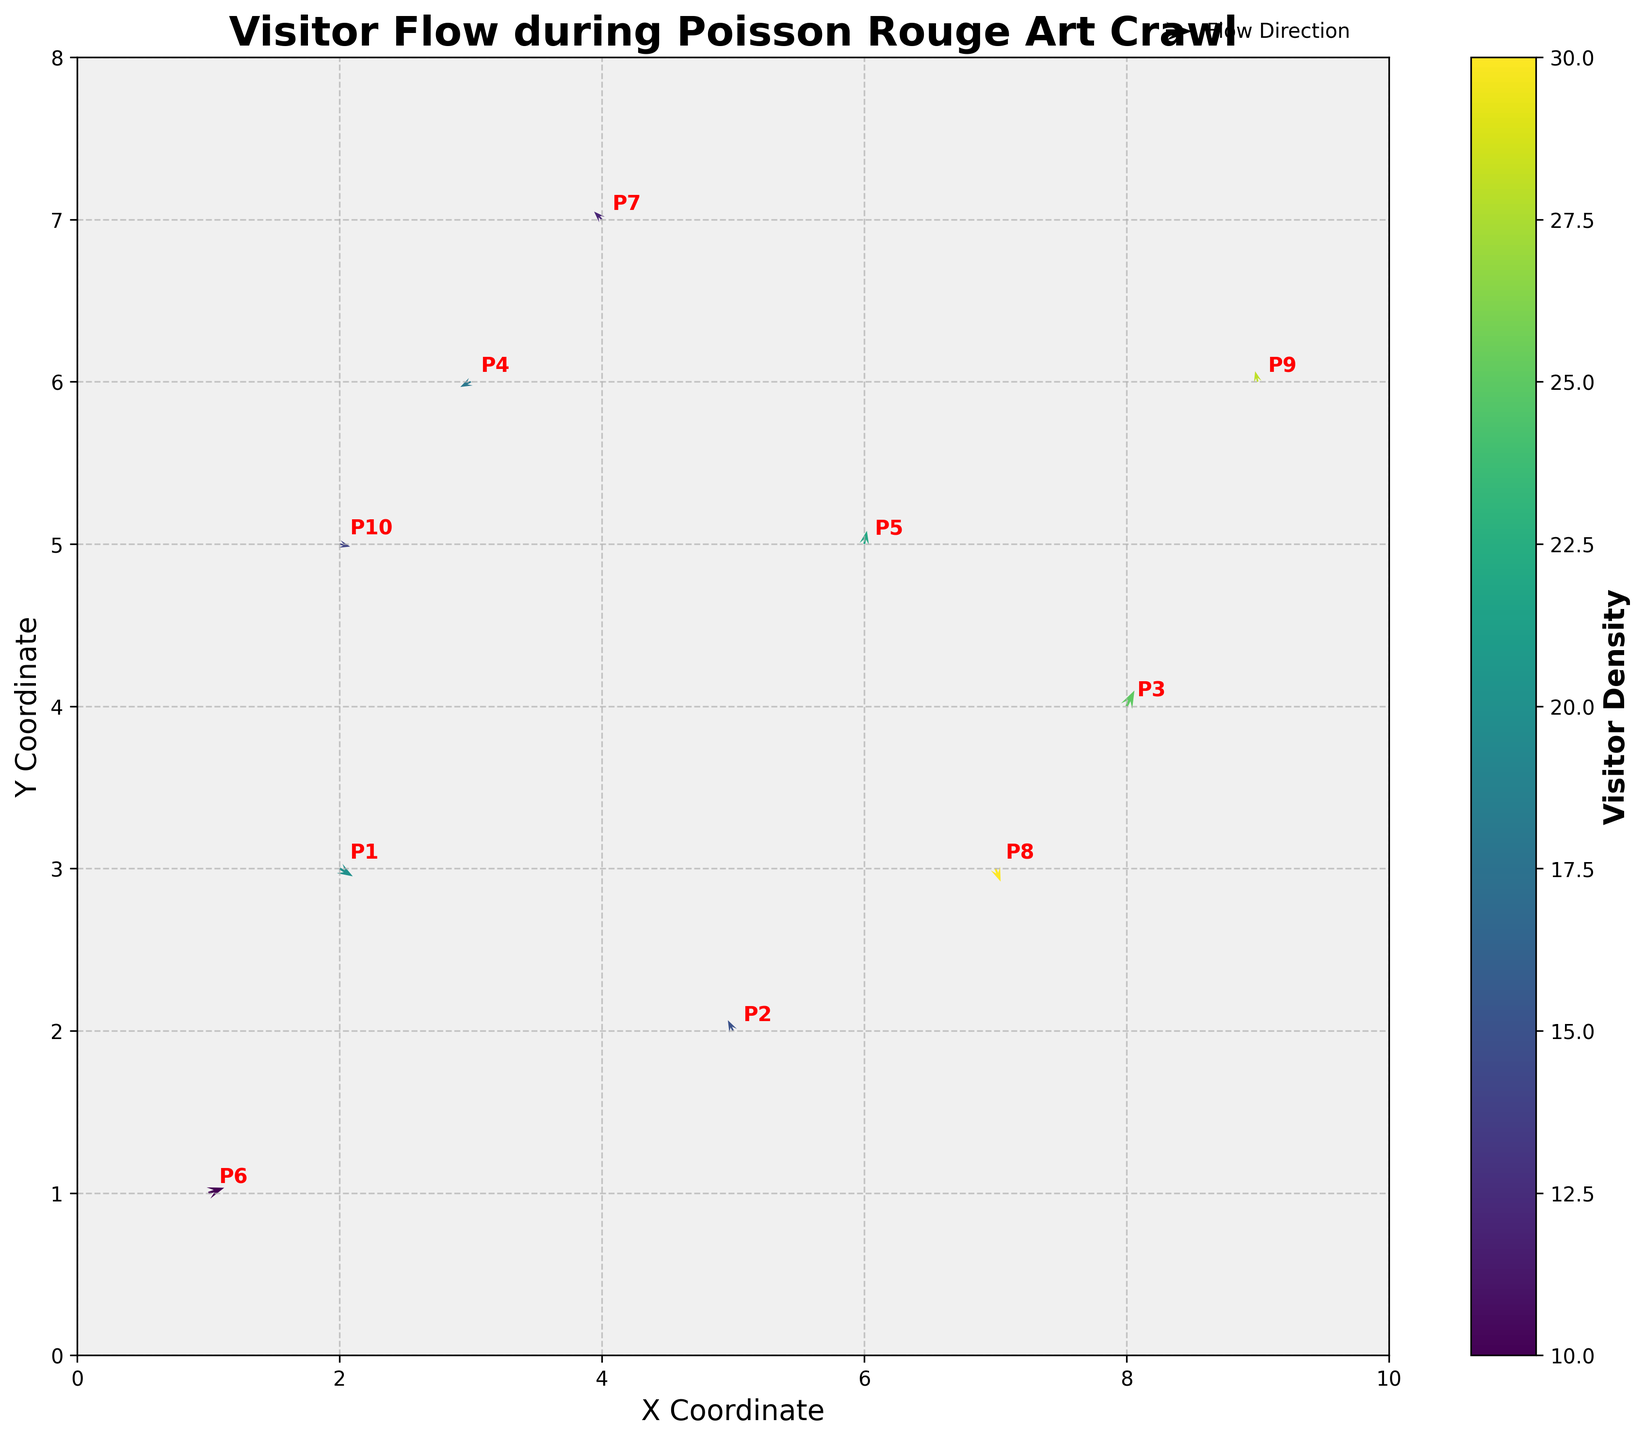What is the title of the plot? The title is usually located at the top of the plot. In this case, it describes the figure's purpose and context.
Answer: Visitor Flow during Poisson Rouge Art Crawl What are the x and y coordinates of P4? The annotations next to each point indicate its label. The one labeled P4 has coordinates (3, 6).
Answer: (3, 6) What does the color represent in the plot? The color of the arrows represents visitor density, as indicated by the colorbar on the side of the plot.
Answer: Visitor Density What is the scale used in the plot for the vectors? The quiver key explains that the scale of the vectors is 1 unit represents a certain magnitude, specifically noted in the legend near the key.
Answer: 1 unit Which point shows the highest visitor density? The colorbar indicates the density with different colors. The point with the darkest color represents the highest density, which is P8.
Answer: P8 How many points are plotted on the figure? By observing the annotated labels, we can count the number of points from P1 to P10, totaling 10 data points.
Answer: 10 Which direction is the vector at P7 pointing to? The vector at P7 points downward as indicated by the arrow direction, following the u and v components supplied in the data.
Answer: Downward Compare the visitor density at P3 and P6. Which one is higher? By comparing the color shades of the vectors at P3 and P6, and referencing the colorbar, the density at P6 is higher.
Answer: P6 What are the X coordinates of the points where the direction of the vector is downward? Downward direction vectors have negative v components. From the data, these points are P1 (2), P4 (3), and P8 (7).
Answer: 2, 3, 7 Which point has the smallest magnitude of the visitor flow, and what is its direction? The magnitude scale can be inferred from the data and represented by the length of vectors. The shortest vector indicates the smallest magnitude, which is P6. By checking data, the direction of P6 vector is upwards.
Answer: P6, upwards 